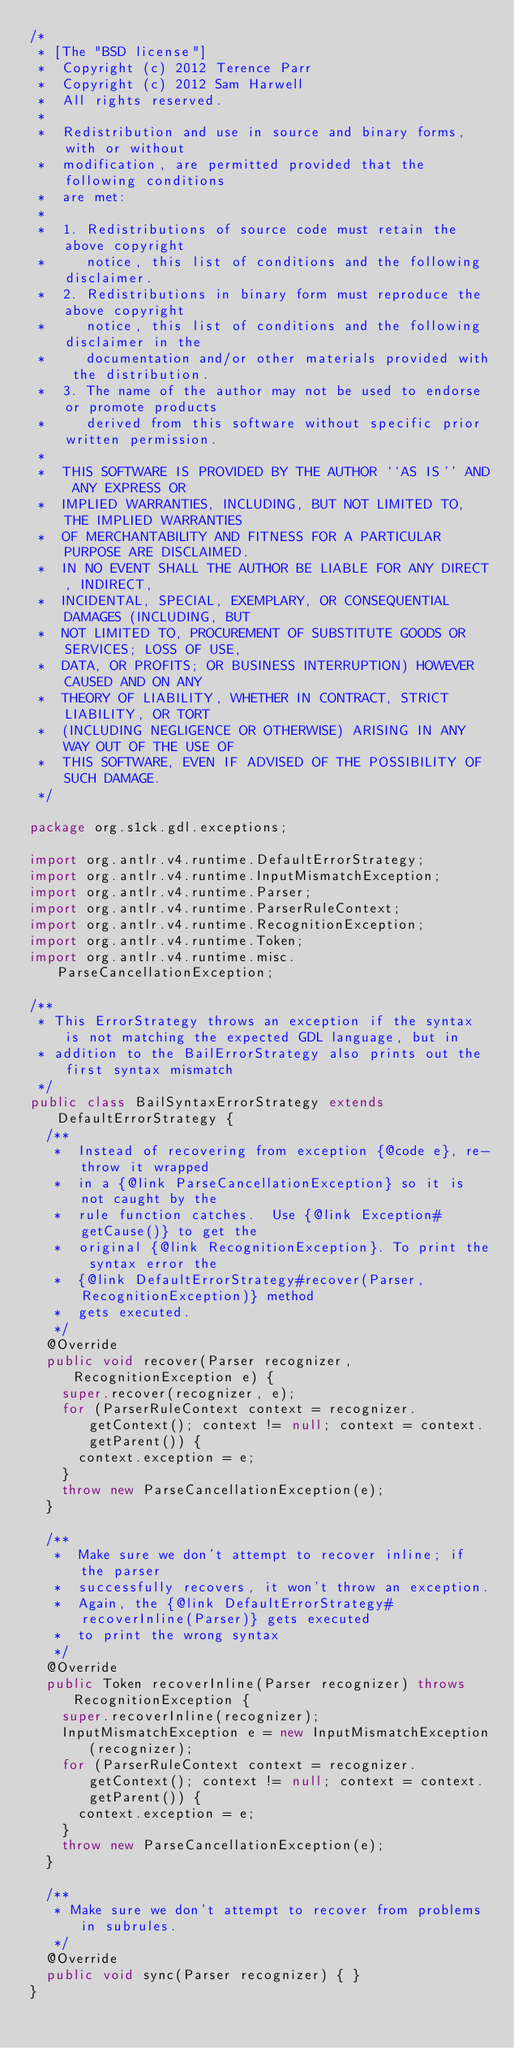Convert code to text. <code><loc_0><loc_0><loc_500><loc_500><_Java_>/*
 * [The "BSD license"]
 *  Copyright (c) 2012 Terence Parr
 *  Copyright (c) 2012 Sam Harwell
 *  All rights reserved.
 *
 *  Redistribution and use in source and binary forms, with or without
 *  modification, are permitted provided that the following conditions
 *  are met:
 *
 *  1. Redistributions of source code must retain the above copyright
 *     notice, this list of conditions and the following disclaimer.
 *  2. Redistributions in binary form must reproduce the above copyright
 *     notice, this list of conditions and the following disclaimer in the
 *     documentation and/or other materials provided with the distribution.
 *  3. The name of the author may not be used to endorse or promote products
 *     derived from this software without specific prior written permission.
 *
 *  THIS SOFTWARE IS PROVIDED BY THE AUTHOR ``AS IS'' AND ANY EXPRESS OR
 *  IMPLIED WARRANTIES, INCLUDING, BUT NOT LIMITED TO, THE IMPLIED WARRANTIES
 *  OF MERCHANTABILITY AND FITNESS FOR A PARTICULAR PURPOSE ARE DISCLAIMED.
 *  IN NO EVENT SHALL THE AUTHOR BE LIABLE FOR ANY DIRECT, INDIRECT,
 *  INCIDENTAL, SPECIAL, EXEMPLARY, OR CONSEQUENTIAL DAMAGES (INCLUDING, BUT
 *  NOT LIMITED TO, PROCUREMENT OF SUBSTITUTE GOODS OR SERVICES; LOSS OF USE,
 *  DATA, OR PROFITS; OR BUSINESS INTERRUPTION) HOWEVER CAUSED AND ON ANY
 *  THEORY OF LIABILITY, WHETHER IN CONTRACT, STRICT LIABILITY, OR TORT
 *  (INCLUDING NEGLIGENCE OR OTHERWISE) ARISING IN ANY WAY OUT OF THE USE OF
 *  THIS SOFTWARE, EVEN IF ADVISED OF THE POSSIBILITY OF SUCH DAMAGE.
 */

package org.s1ck.gdl.exceptions;

import org.antlr.v4.runtime.DefaultErrorStrategy;
import org.antlr.v4.runtime.InputMismatchException;
import org.antlr.v4.runtime.Parser;
import org.antlr.v4.runtime.ParserRuleContext;
import org.antlr.v4.runtime.RecognitionException;
import org.antlr.v4.runtime.Token;
import org.antlr.v4.runtime.misc.ParseCancellationException;

/**
 * This ErrorStrategy throws an exception if the syntax is not matching the expected GDL language, but in
 * addition to the BailErrorStrategy also prints out the first syntax mismatch
 */
public class BailSyntaxErrorStrategy extends DefaultErrorStrategy {
  /**
   *  Instead of recovering from exception {@code e}, re-throw it wrapped
   *  in a {@link ParseCancellationException} so it is not caught by the
   *  rule function catches.  Use {@link Exception#getCause()} to get the
   *  original {@link RecognitionException}. To print the syntax error the
   *  {@link DefaultErrorStrategy#recover(Parser, RecognitionException)} method
   *  gets executed.
   */
  @Override
  public void recover(Parser recognizer, RecognitionException e) {
    super.recover(recognizer, e);
    for (ParserRuleContext context = recognizer.getContext(); context != null; context = context.getParent()) {
      context.exception = e;
    }
    throw new ParseCancellationException(e);
  }

  /**
   *  Make sure we don't attempt to recover inline; if the parser
   *  successfully recovers, it won't throw an exception.
   *  Again, the {@link DefaultErrorStrategy#recoverInline(Parser)} gets executed
   *  to print the wrong syntax
   */
  @Override
  public Token recoverInline(Parser recognizer) throws RecognitionException {
    super.recoverInline(recognizer);
    InputMismatchException e = new InputMismatchException(recognizer);
    for (ParserRuleContext context = recognizer.getContext(); context != null; context = context.getParent()) {
      context.exception = e;
    }
    throw new ParseCancellationException(e);
  }

  /**
   * Make sure we don't attempt to recover from problems in subrules.
   */
  @Override
  public void sync(Parser recognizer) { }
}
</code> 